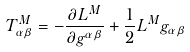Convert formula to latex. <formula><loc_0><loc_0><loc_500><loc_500>T ^ { M } _ { \alpha \beta } = - \frac { \partial L ^ { M } } { \partial g ^ { \alpha \beta } } + \frac { 1 } { 2 } L ^ { M } g _ { \alpha \beta }</formula> 